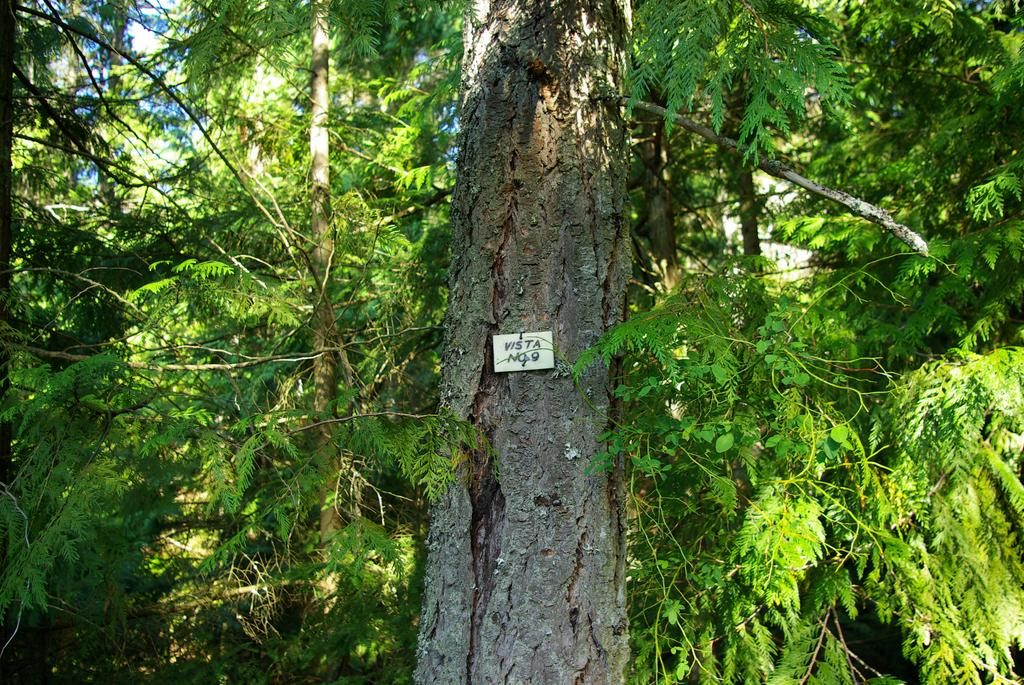What is the main object in the foreground of the image? There is a tree trunk in the image. Is there anything attached to the tree trunk? Yes, there is a small board on the tree trunk. What can be seen in the background of the image? Trees and the sky are visible in the background of the image. What type of leather is being used to write on the tree trunk in the image? There is no leather or writing present in the image; it only features a tree trunk and a small board. 